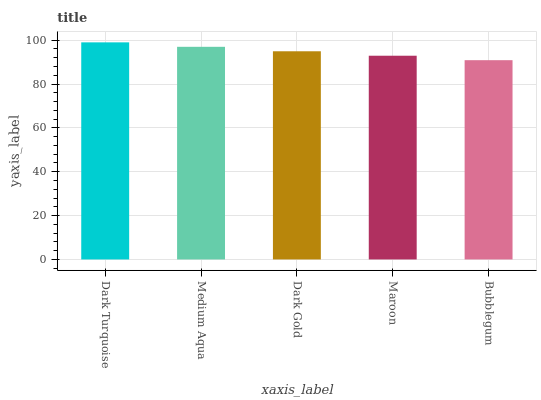Is Medium Aqua the minimum?
Answer yes or no. No. Is Medium Aqua the maximum?
Answer yes or no. No. Is Dark Turquoise greater than Medium Aqua?
Answer yes or no. Yes. Is Medium Aqua less than Dark Turquoise?
Answer yes or no. Yes. Is Medium Aqua greater than Dark Turquoise?
Answer yes or no. No. Is Dark Turquoise less than Medium Aqua?
Answer yes or no. No. Is Dark Gold the high median?
Answer yes or no. Yes. Is Dark Gold the low median?
Answer yes or no. Yes. Is Medium Aqua the high median?
Answer yes or no. No. Is Bubblegum the low median?
Answer yes or no. No. 